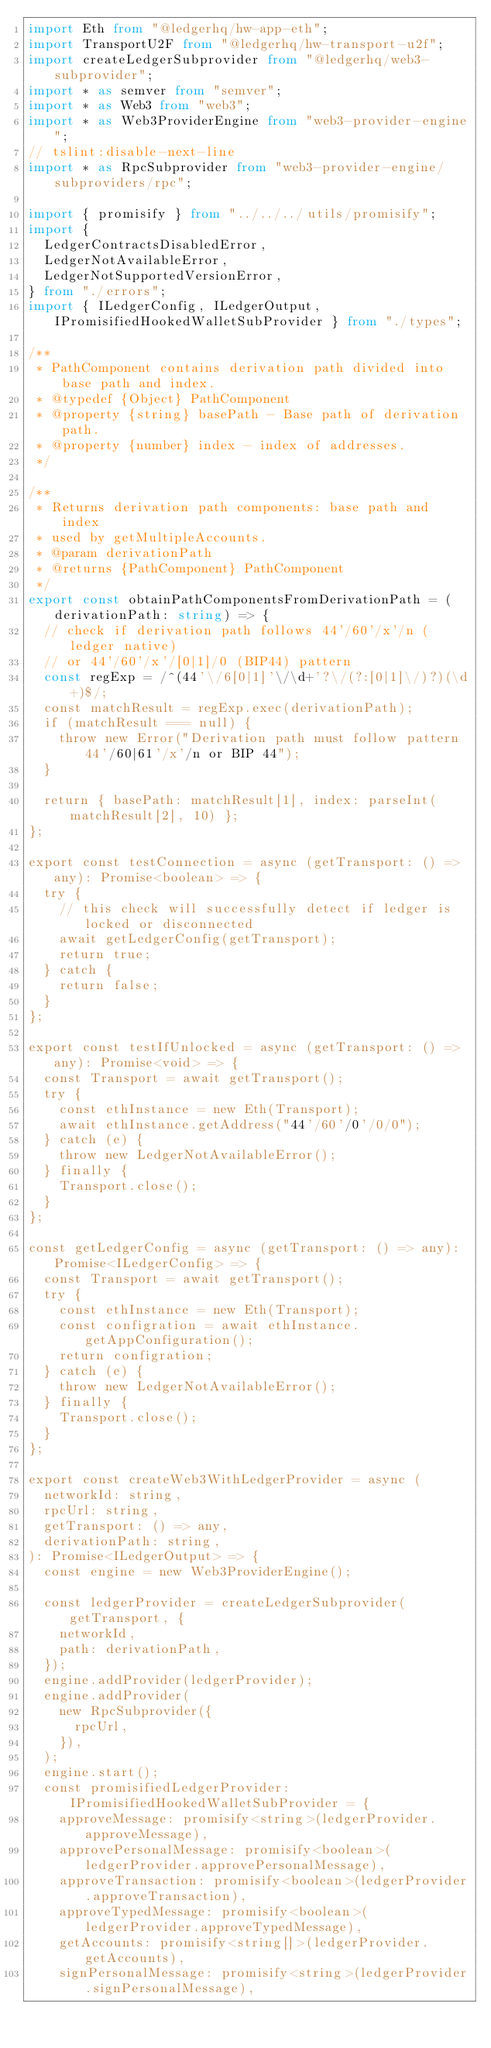Convert code to text. <code><loc_0><loc_0><loc_500><loc_500><_TypeScript_>import Eth from "@ledgerhq/hw-app-eth";
import TransportU2F from "@ledgerhq/hw-transport-u2f";
import createLedgerSubprovider from "@ledgerhq/web3-subprovider";
import * as semver from "semver";
import * as Web3 from "web3";
import * as Web3ProviderEngine from "web3-provider-engine";
// tslint:disable-next-line
import * as RpcSubprovider from "web3-provider-engine/subproviders/rpc";

import { promisify } from "../../../utils/promisify";
import {
  LedgerContractsDisabledError,
  LedgerNotAvailableError,
  LedgerNotSupportedVersionError,
} from "./errors";
import { ILedgerConfig, ILedgerOutput, IPromisifiedHookedWalletSubProvider } from "./types";

/**
 * PathComponent contains derivation path divided into base path and index.
 * @typedef {Object} PathComponent
 * @property {string} basePath - Base path of derivation path.
 * @property {number} index - index of addresses.
 */

/**
 * Returns derivation path components: base path and index
 * used by getMultipleAccounts.
 * @param derivationPath
 * @returns {PathComponent} PathComponent
 */
export const obtainPathComponentsFromDerivationPath = (derivationPath: string) => {
  // check if derivation path follows 44'/60'/x'/n (ledger native)
  // or 44'/60'/x'/[0|1]/0 (BIP44) pattern
  const regExp = /^(44'\/6[0|1]'\/\d+'?\/(?:[0|1]\/)?)(\d+)$/;
  const matchResult = regExp.exec(derivationPath);
  if (matchResult === null) {
    throw new Error("Derivation path must follow pattern 44'/60|61'/x'/n or BIP 44");
  }

  return { basePath: matchResult[1], index: parseInt(matchResult[2], 10) };
};

export const testConnection = async (getTransport: () => any): Promise<boolean> => {
  try {
    // this check will successfully detect if ledger is locked or disconnected
    await getLedgerConfig(getTransport);
    return true;
  } catch {
    return false;
  }
};

export const testIfUnlocked = async (getTransport: () => any): Promise<void> => {
  const Transport = await getTransport();
  try {
    const ethInstance = new Eth(Transport);
    await ethInstance.getAddress("44'/60'/0'/0/0");
  } catch (e) {
    throw new LedgerNotAvailableError();
  } finally {
    Transport.close();
  }
};

const getLedgerConfig = async (getTransport: () => any): Promise<ILedgerConfig> => {
  const Transport = await getTransport();
  try {
    const ethInstance = new Eth(Transport);
    const configration = await ethInstance.getAppConfiguration();
    return configration;
  } catch (e) {
    throw new LedgerNotAvailableError();
  } finally {
    Transport.close();
  }
};

export const createWeb3WithLedgerProvider = async (
  networkId: string,
  rpcUrl: string,
  getTransport: () => any,
  derivationPath: string,
): Promise<ILedgerOutput> => {
  const engine = new Web3ProviderEngine();

  const ledgerProvider = createLedgerSubprovider(getTransport, {
    networkId,
    path: derivationPath,
  });
  engine.addProvider(ledgerProvider);
  engine.addProvider(
    new RpcSubprovider({
      rpcUrl,
    }),
  );
  engine.start();
  const promisifiedLedgerProvider: IPromisifiedHookedWalletSubProvider = {
    approveMessage: promisify<string>(ledgerProvider.approveMessage),
    approvePersonalMessage: promisify<boolean>(ledgerProvider.approvePersonalMessage),
    approveTransaction: promisify<boolean>(ledgerProvider.approveTransaction),
    approveTypedMessage: promisify<boolean>(ledgerProvider.approveTypedMessage),
    getAccounts: promisify<string[]>(ledgerProvider.getAccounts),
    signPersonalMessage: promisify<string>(ledgerProvider.signPersonalMessage),</code> 